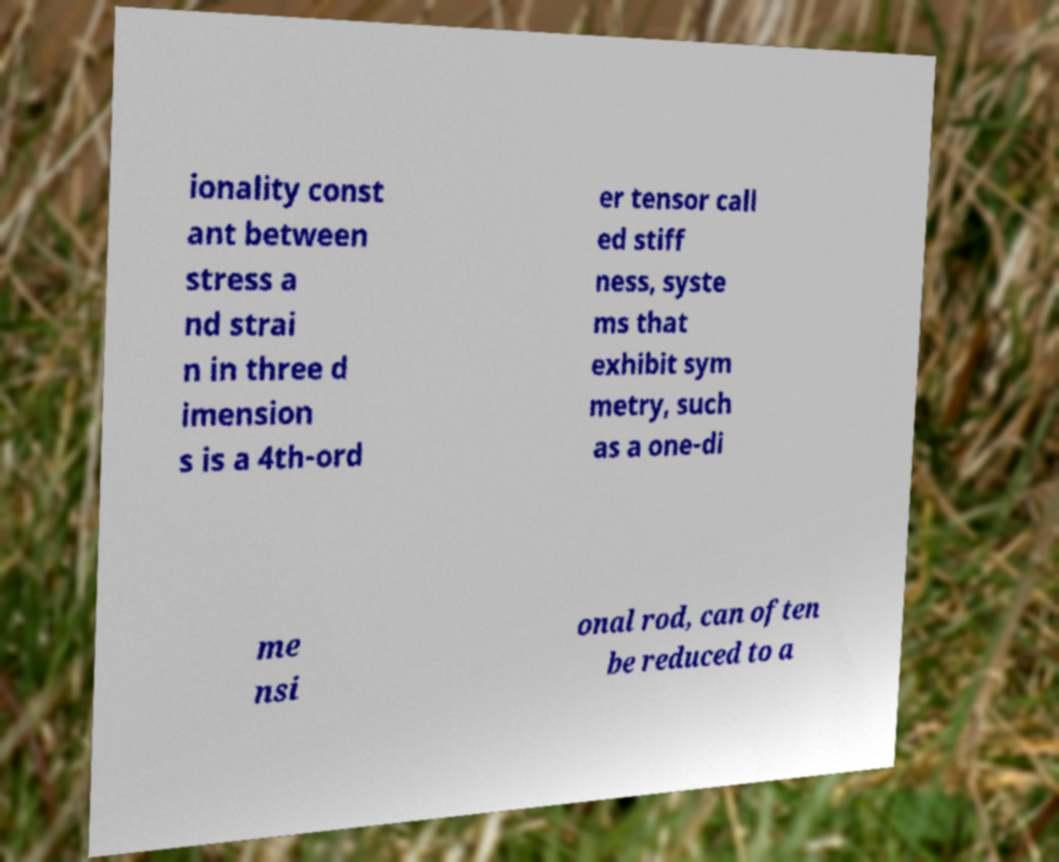I need the written content from this picture converted into text. Can you do that? ionality const ant between stress a nd strai n in three d imension s is a 4th-ord er tensor call ed stiff ness, syste ms that exhibit sym metry, such as a one-di me nsi onal rod, can often be reduced to a 